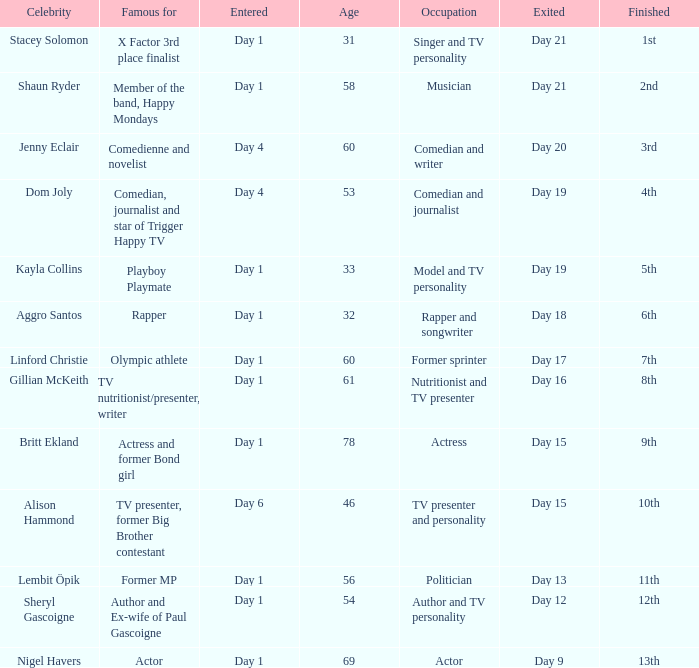What position did the celebrity finish that entered on day 1 and exited on day 15? 9th. 